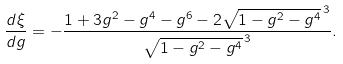Convert formula to latex. <formula><loc_0><loc_0><loc_500><loc_500>\frac { d \xi } { d g } = - \frac { 1 + 3 g ^ { 2 } - g ^ { 4 } - g ^ { 6 } - 2 \sqrt { 1 - g ^ { 2 } - g ^ { 4 } } ^ { \, 3 } } { \sqrt { 1 - g ^ { 2 } - g ^ { 4 } } ^ { \, 3 } } .</formula> 